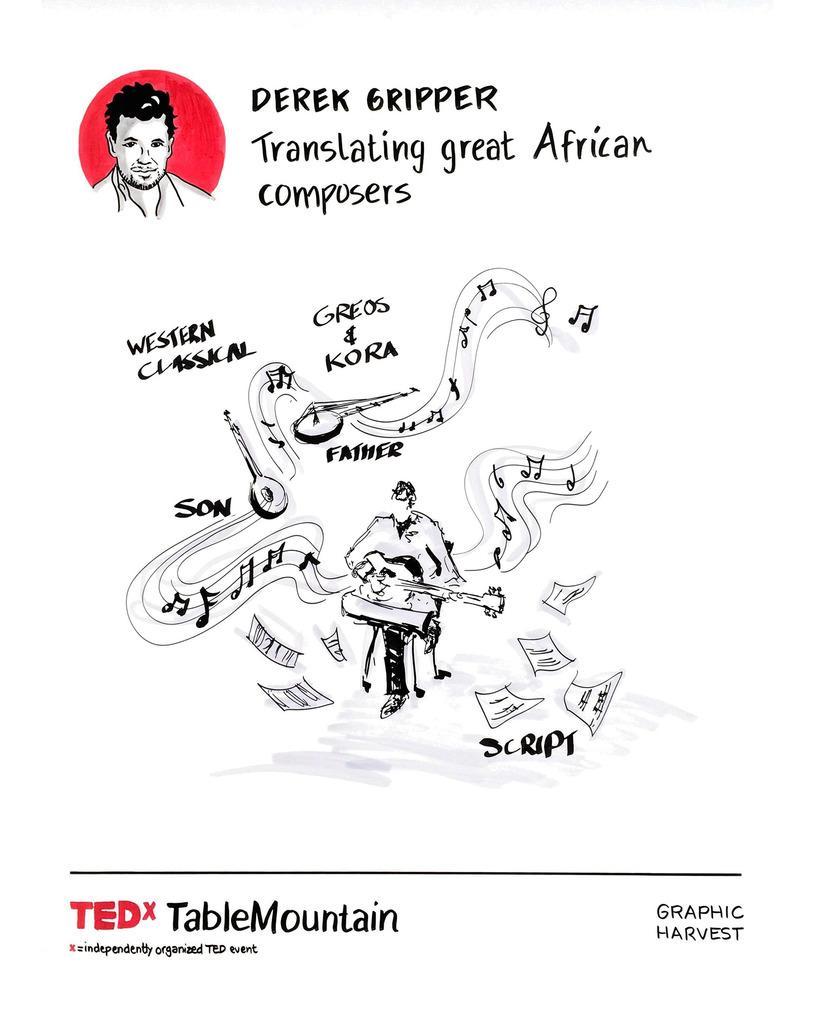How would you summarize this image in a sentence or two? In this image I can see a poster in which I can see a person is sitting and holding a musical instrument, few papers, something is written and a picture of a person. 